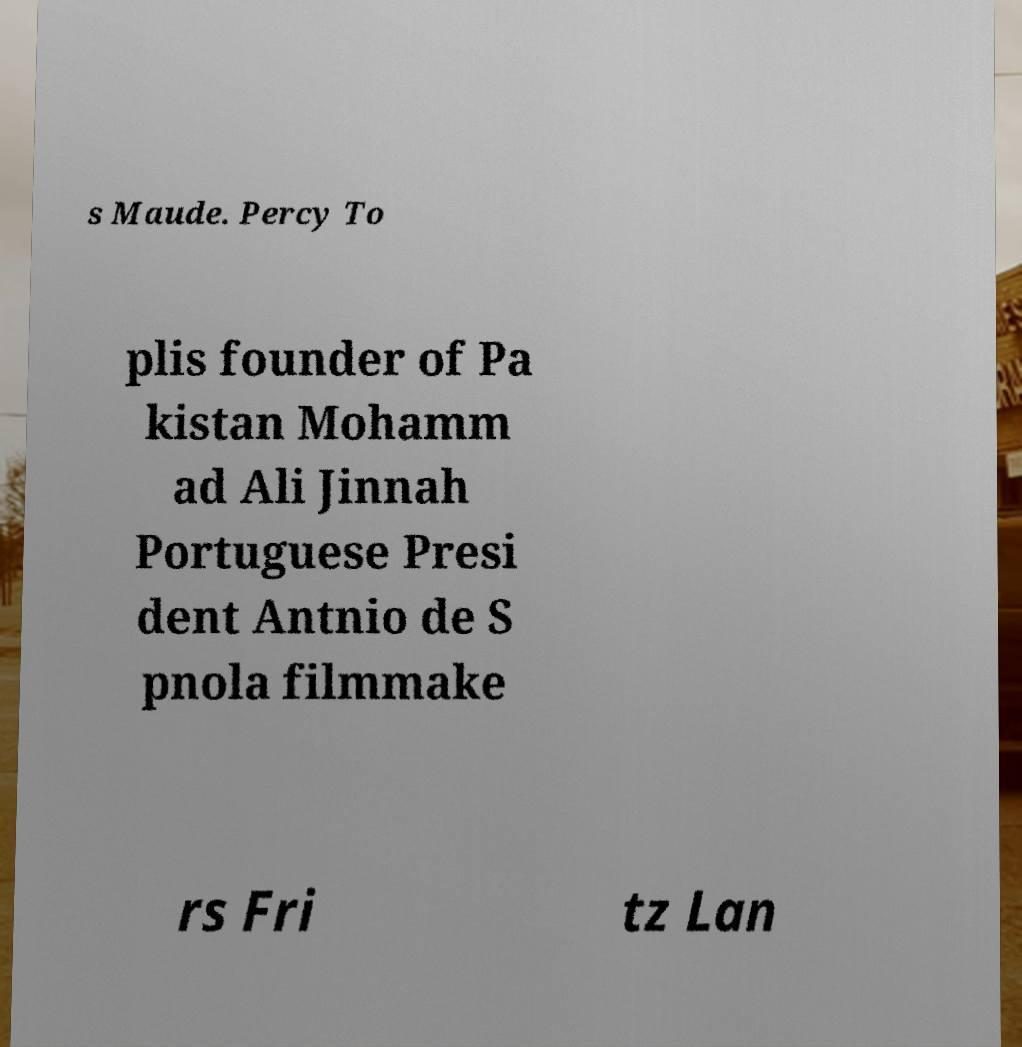What messages or text are displayed in this image? I need them in a readable, typed format. s Maude. Percy To plis founder of Pa kistan Mohamm ad Ali Jinnah Portuguese Presi dent Antnio de S pnola filmmake rs Fri tz Lan 